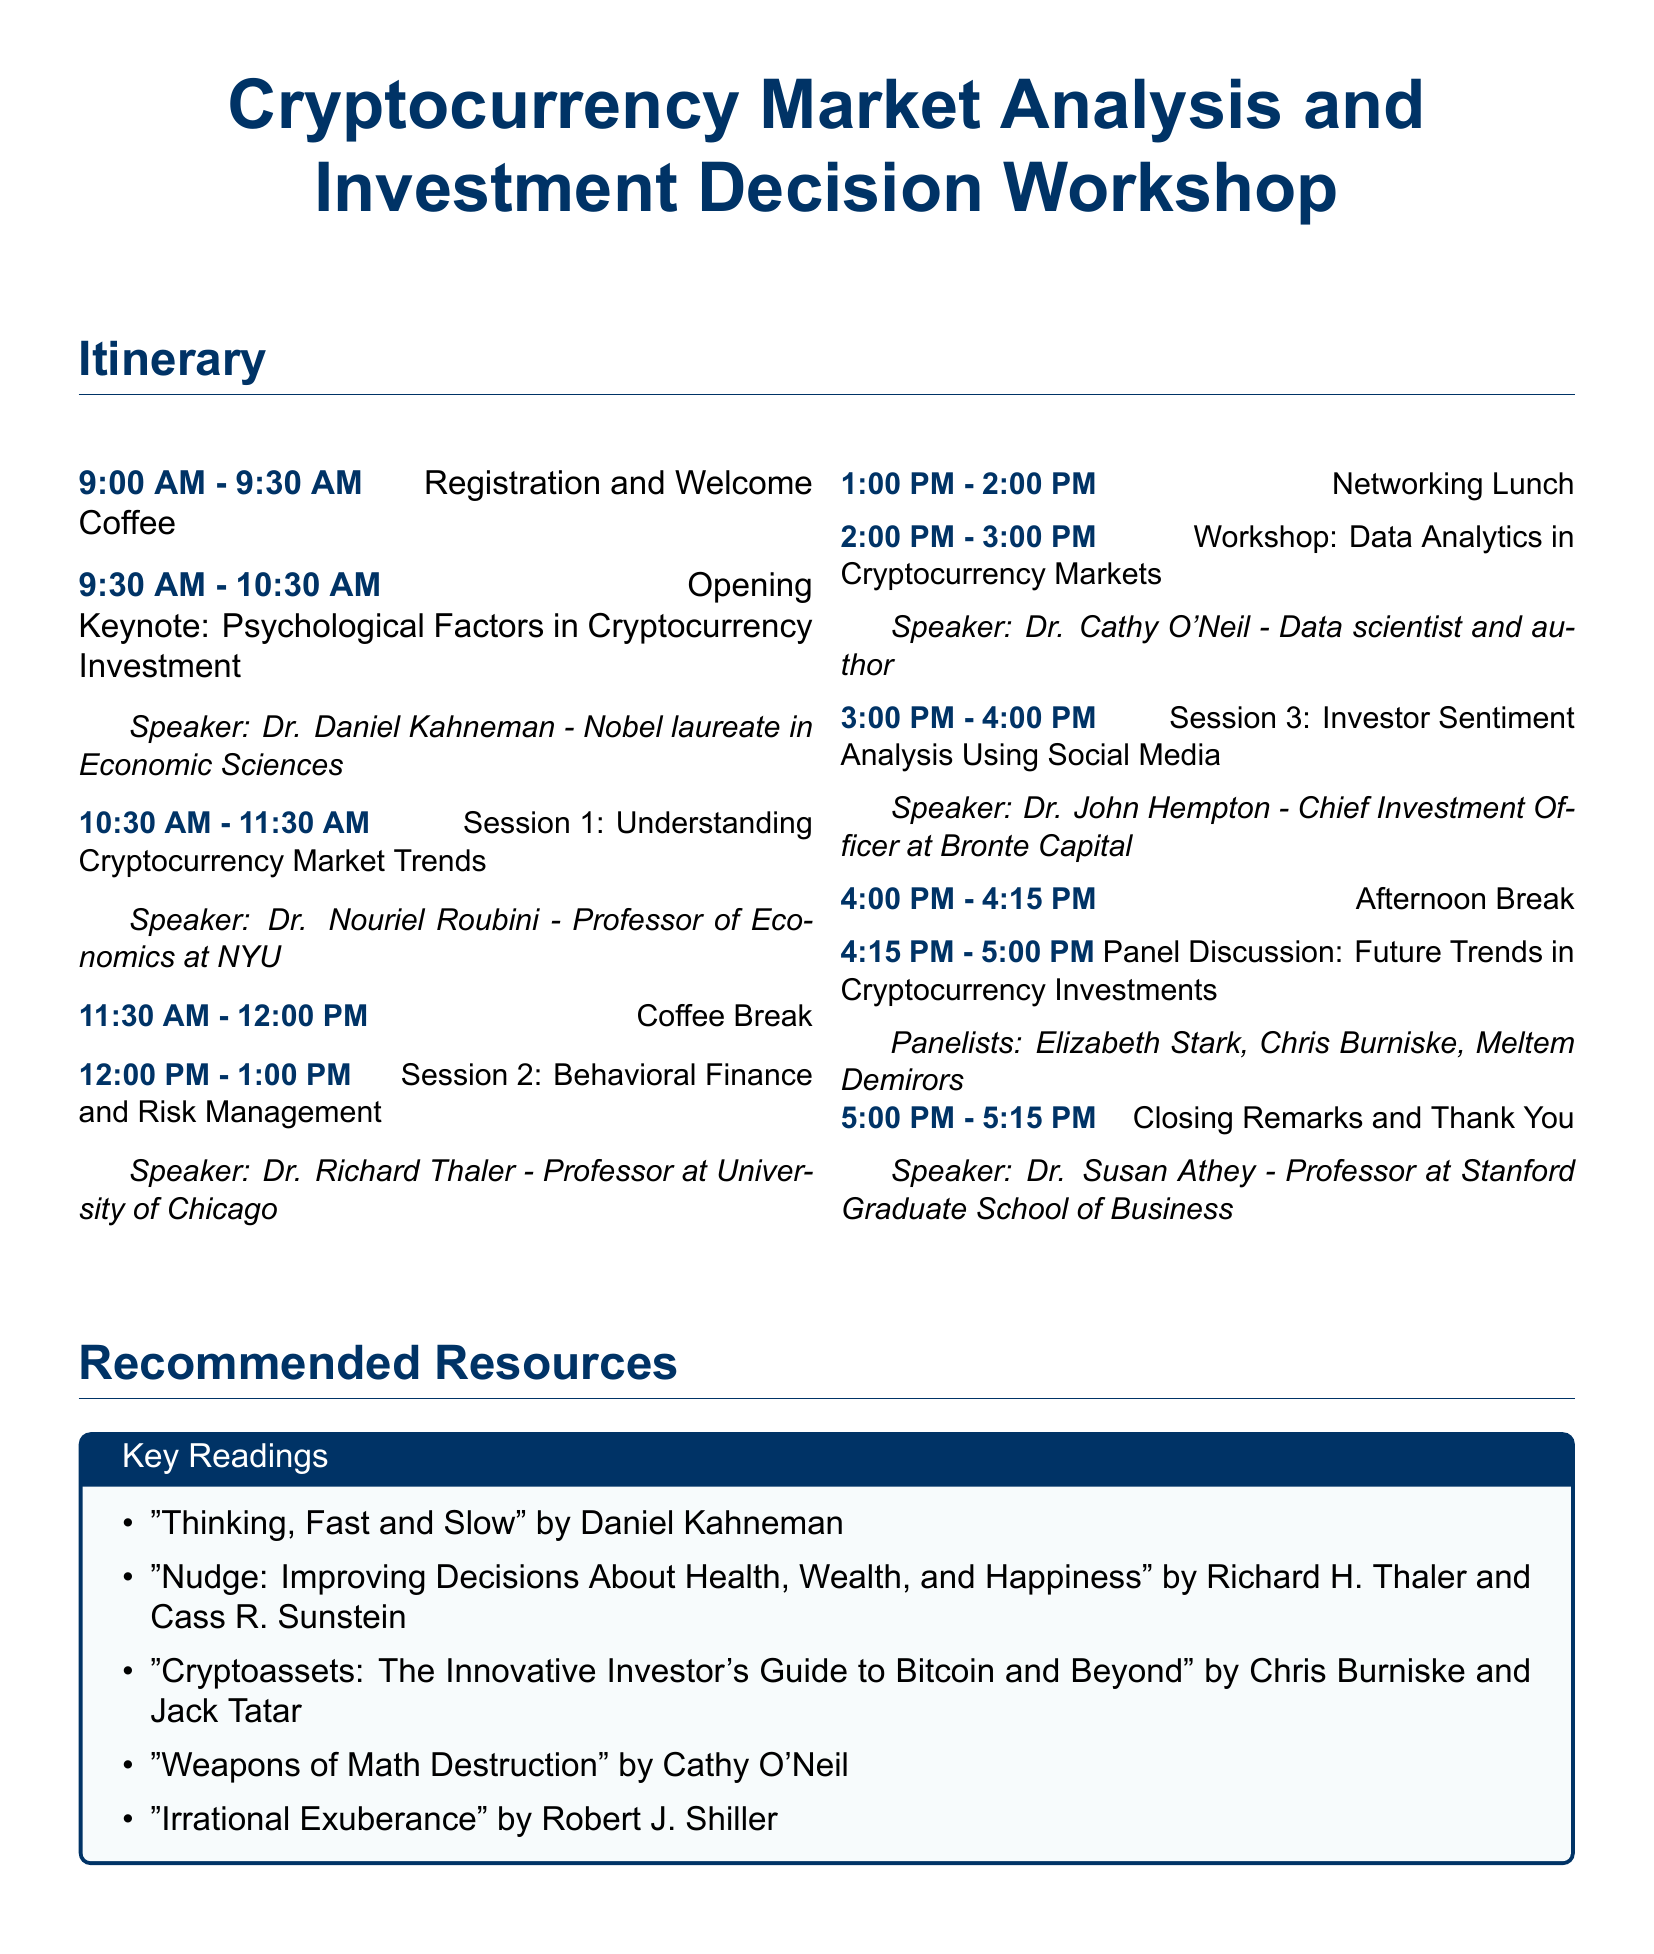What time does registration start? The registration starts at 9:00 AM, as indicated in the itinerary.
Answer: 9:00 AM Who is the speaker for the Opening Keynote? The speaker for the Opening Keynote is listed as Dr. Daniel Kahneman.
Answer: Dr. Daniel Kahneman What is the topic of Session 2? Session 2 focuses on Behavioral Finance and Risk Management, which can be found in the itinerary.
Answer: Behavioral Finance and Risk Management How long is the coffee break? The coffee break is scheduled for 30 minutes, as noted between sessions.
Answer: 30 minutes What is the title of the recommended resource by Daniel Kahneman? The recommended reading by Daniel Kahneman is titled "Thinking, Fast and Slow."
Answer: Thinking, Fast and Slow Who are the panelists in the panel discussion? The panelists in the discussion include Elizabeth Stark, Chris Burniske, and Meltem Demirors.
Answer: Elizabeth Stark, Chris Burniske, Meltem Demirors What time does the workshop on Data Analytics start? The workshop on Data Analytics starts at 2:00 PM, as indicated in the itinerary.
Answer: 2:00 PM Which speaker is a Chief Investment Officer? The speaker identified as the Chief Investment Officer is Dr. John Hempton.
Answer: Dr. John Hempton How many sessions are there in total? There are a total of three sessions mentioned in the itinerary.
Answer: Three sessions 